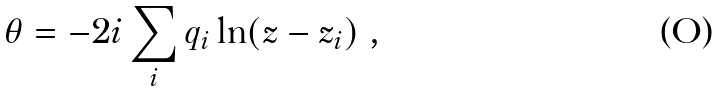<formula> <loc_0><loc_0><loc_500><loc_500>\theta = - 2 i \sum _ { i } q _ { i } \ln ( z - z _ { i } ) \ ,</formula> 